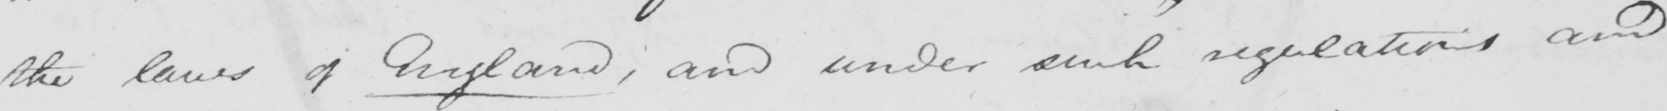What is written in this line of handwriting? the laws of England , and under such regulations and 